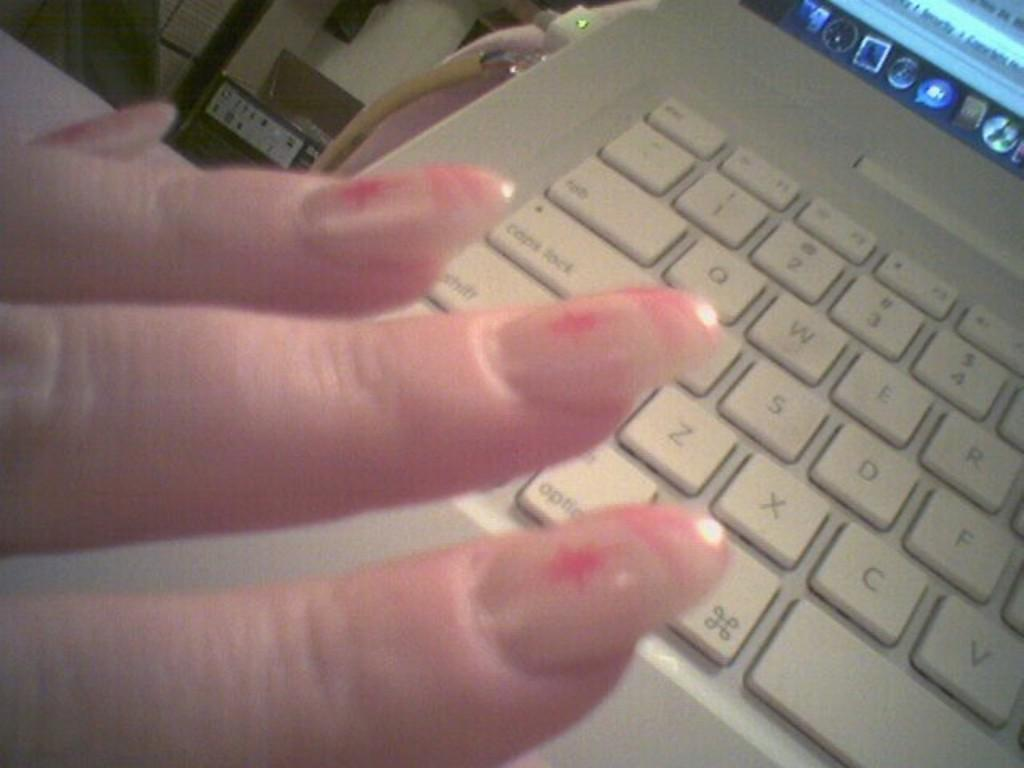What body part is visible on the left side of the image? There are fingers of a person on the left side of the image. What electronic device is on the right side of the image? There is a laptop on the right side of the image. What can be seen in the background of the image? Electrical wires and electronic instruments are visible in the background of the image. What type of tent is set up on the ground in the image? There is no tent or ground present in the image; it features fingers, a laptop, electrical wires, and electronic instruments. What type of flesh is visible on the person's fingers in the image? There is no need to describe the person's fingers in terms of flesh, as the focus is on the presence of fingers and not their physical characteristics. 